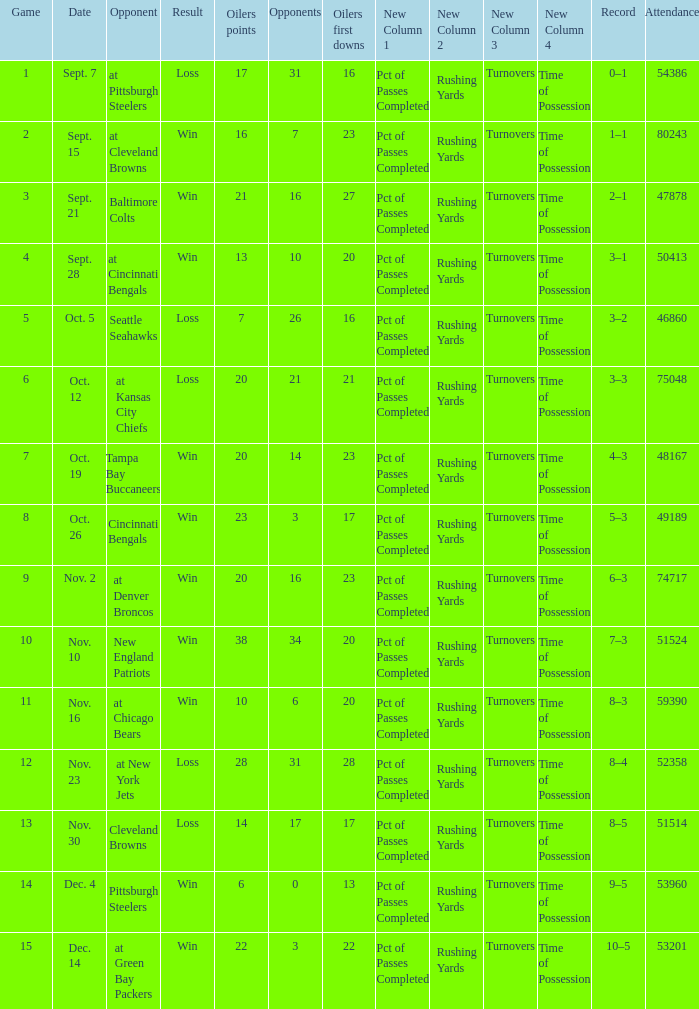What was the total opponents points for the game were the Oilers scored 21? 16.0. 